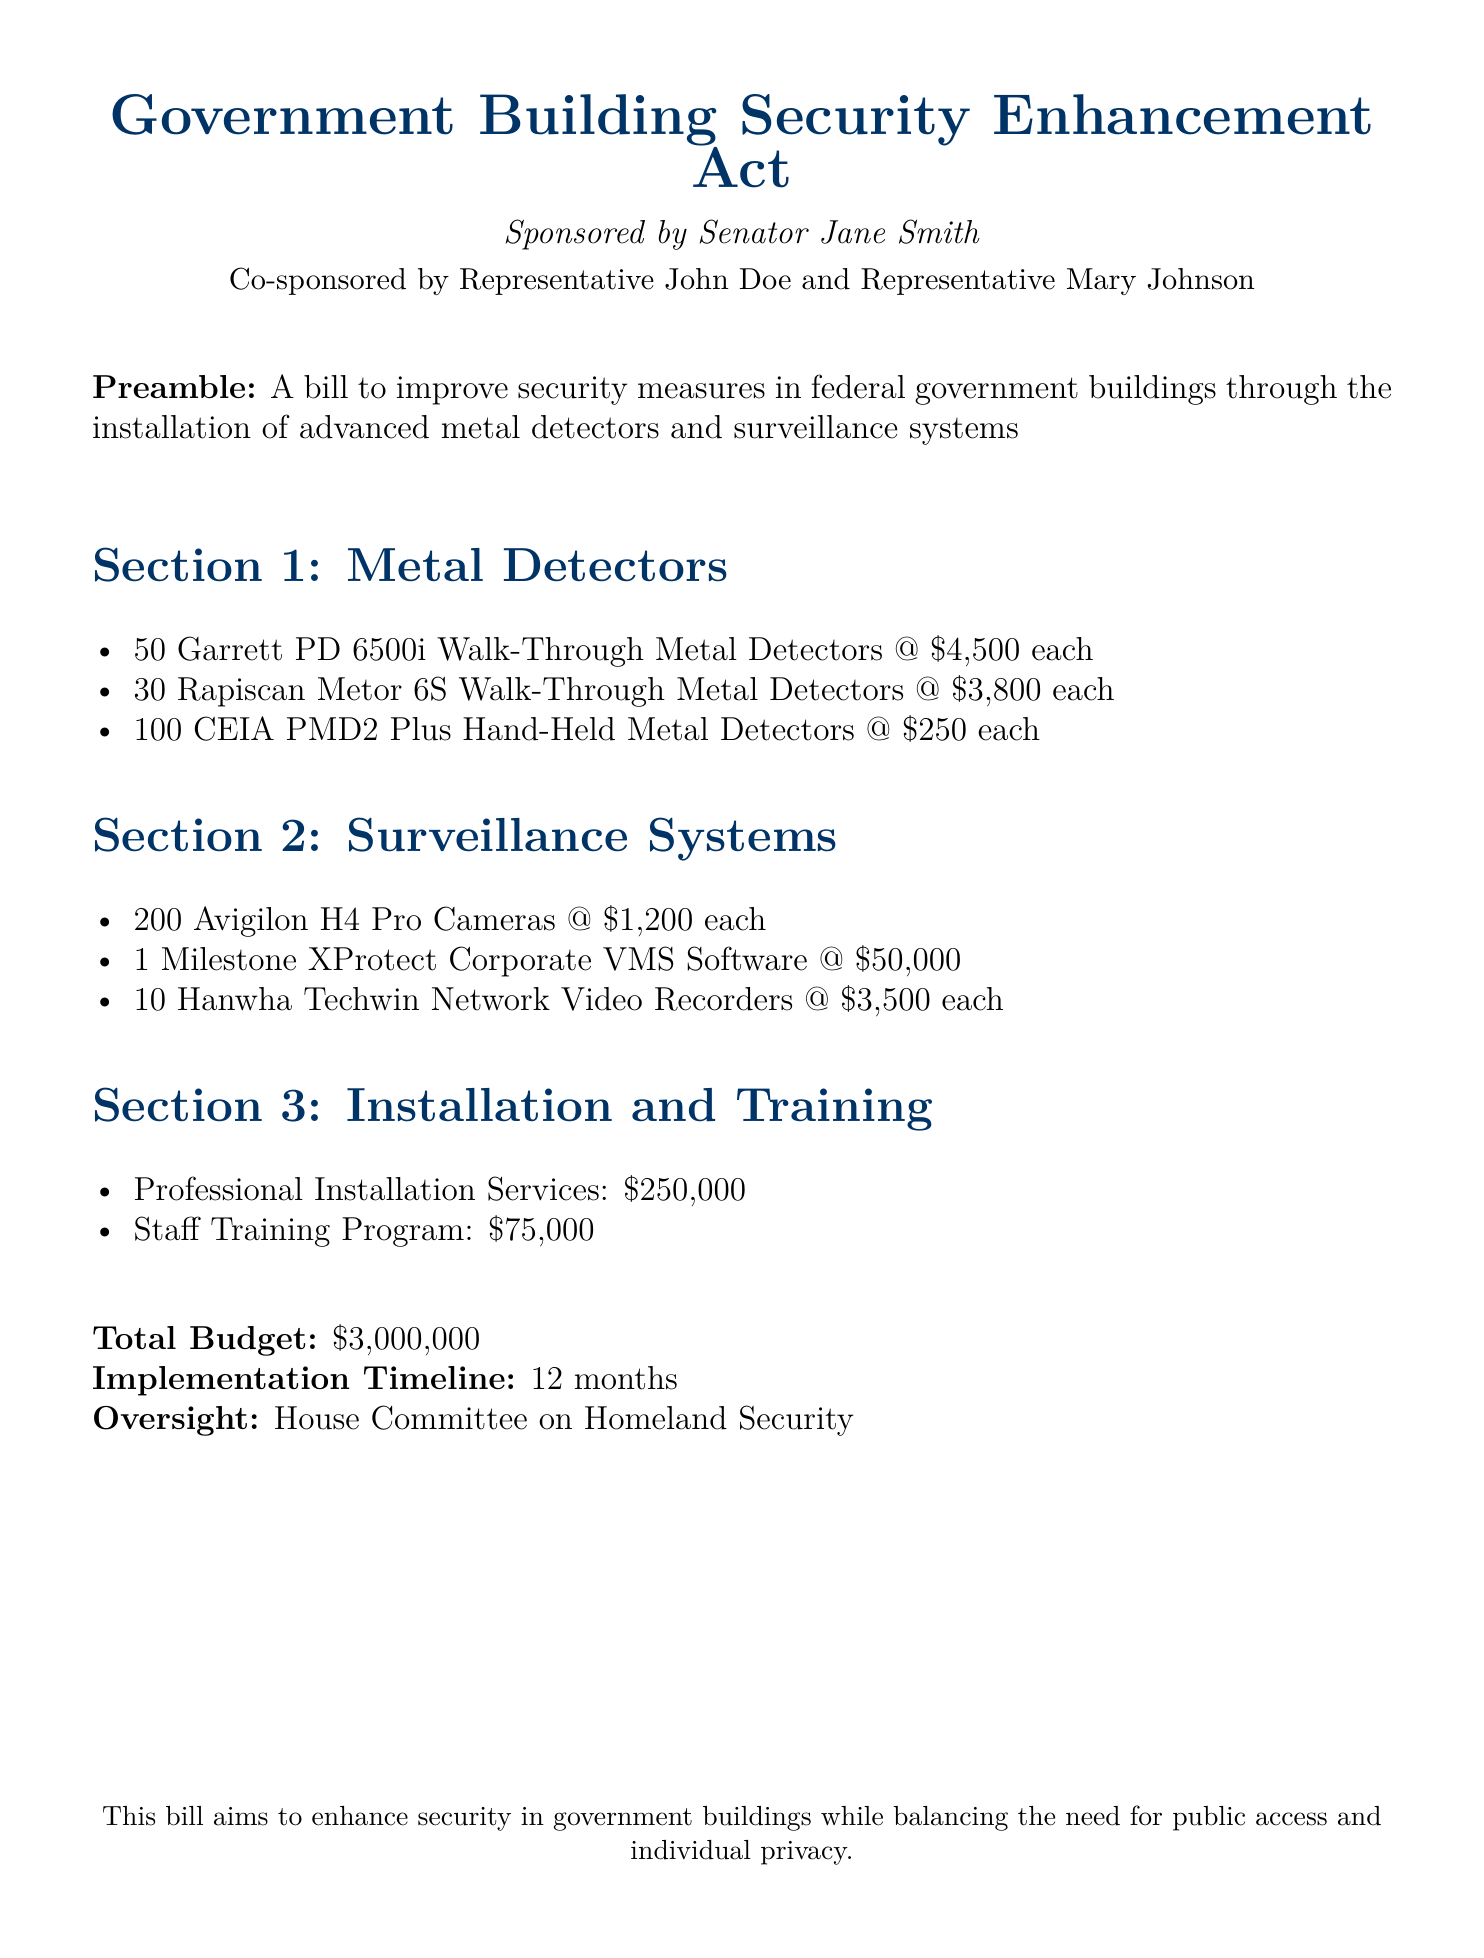What is the total budget? The total budget is clearly stated at the end of the document.
Answer: $3,000,000 How many Garrett PD 6500i Metal Detectors are proposed? This information is listed under Section 1, which details the quantities of each type of metal detector.
Answer: 50 What is the cost of one Milestone XProtect Corporate VMS Software? The price of the software is specified in Section 2 under Surveillance Systems.
Answer: $50,000 How many Hanwha Techwin Network Video Recorders are to be installed? This quantity can be found in Section 2, which lists the proposed surveillance system components.
Answer: 10 What is the estimated timeline for implementation? The timeline is mentioned as part of the overview of the project’s execution in the document.
Answer: 12 months What oversight committee is involved in this bill? The oversight authority is stated towards the end of the document under the oversight section.
Answer: House Committee on Homeland Security How much will the staff training program cost? The cost of the training program is specified in Section 3, which discusses installation and training expenses.
Answer: $75,000 What type of cameras are included in the surveillance systems? The specific model of the cameras is detailed in Section 2, which lists all components of the surveillance systems.
Answer: Avigilon H4 Pro Cameras What is the cost of one CEIA PMD2 Plus Hand-Held Metal Detector? This information can be found in Section 1, where the prices of various detectors are listed.
Answer: $250 